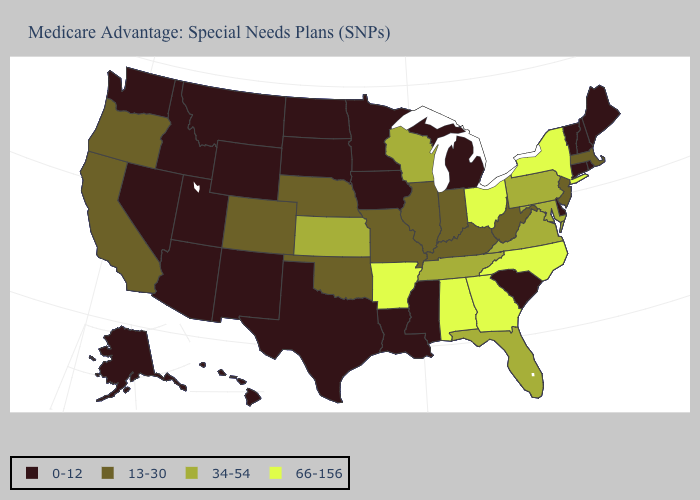Name the states that have a value in the range 13-30?
Concise answer only. California, Colorado, Illinois, Indiana, Kentucky, Massachusetts, Missouri, Nebraska, New Jersey, Oklahoma, Oregon, West Virginia. What is the highest value in the MidWest ?
Write a very short answer. 66-156. Name the states that have a value in the range 0-12?
Answer briefly. Alaska, Arizona, Connecticut, Delaware, Hawaii, Idaho, Iowa, Louisiana, Maine, Michigan, Minnesota, Mississippi, Montana, Nevada, New Hampshire, New Mexico, North Dakota, Rhode Island, South Carolina, South Dakota, Texas, Utah, Vermont, Washington, Wyoming. Among the states that border Nebraska , which have the lowest value?
Keep it brief. Iowa, South Dakota, Wyoming. Does Nevada have the lowest value in the USA?
Write a very short answer. Yes. What is the lowest value in the USA?
Give a very brief answer. 0-12. Name the states that have a value in the range 13-30?
Short answer required. California, Colorado, Illinois, Indiana, Kentucky, Massachusetts, Missouri, Nebraska, New Jersey, Oklahoma, Oregon, West Virginia. Among the states that border Vermont , does New York have the lowest value?
Answer briefly. No. Name the states that have a value in the range 66-156?
Quick response, please. Alabama, Arkansas, Georgia, New York, North Carolina, Ohio. What is the lowest value in the South?
Concise answer only. 0-12. What is the highest value in the South ?
Keep it brief. 66-156. Does Maine have the same value as Rhode Island?
Short answer required. Yes. Does Oklahoma have the lowest value in the USA?
Short answer required. No. How many symbols are there in the legend?
Give a very brief answer. 4. Does Texas have the lowest value in the USA?
Give a very brief answer. Yes. 